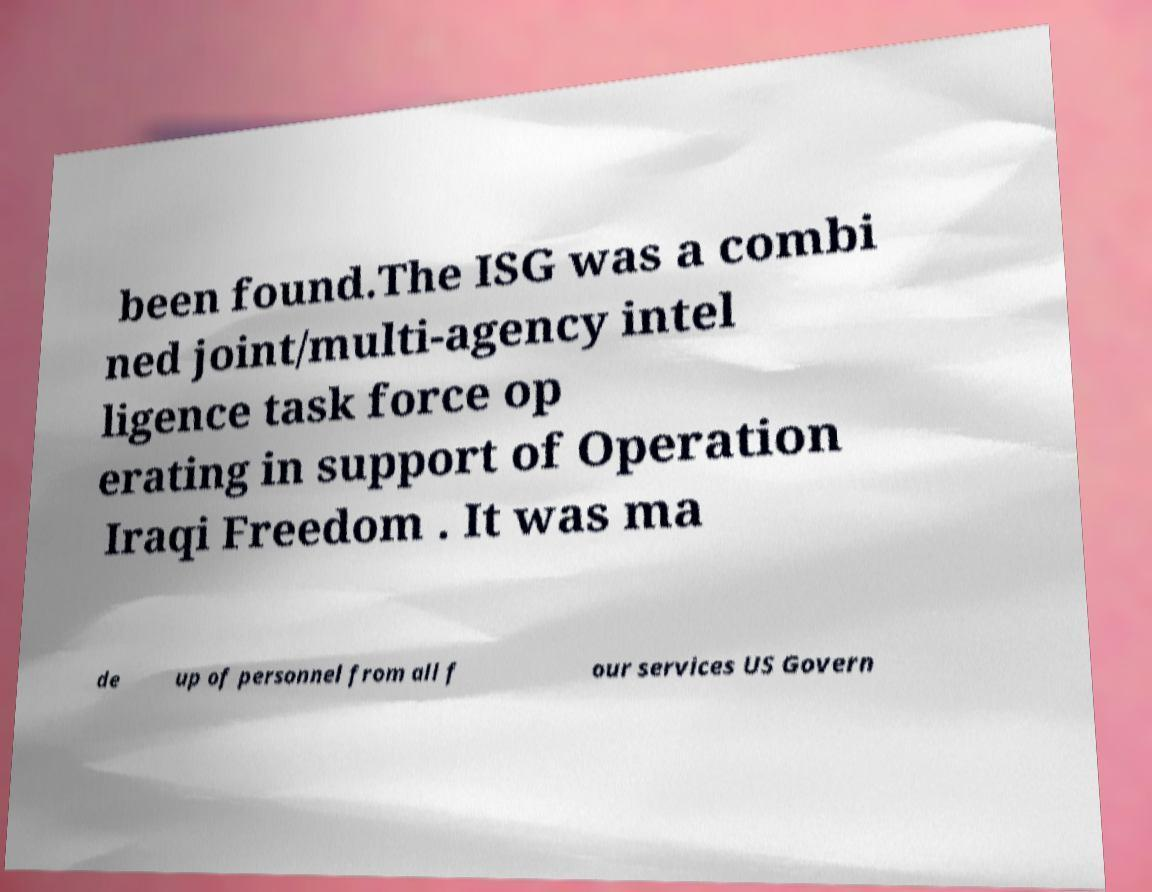Could you assist in decoding the text presented in this image and type it out clearly? been found.The ISG was a combi ned joint/multi-agency intel ligence task force op erating in support of Operation Iraqi Freedom . It was ma de up of personnel from all f our services US Govern 